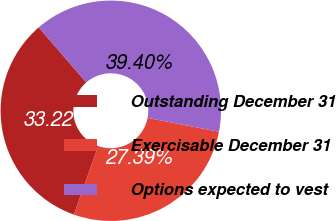Convert chart to OTSL. <chart><loc_0><loc_0><loc_500><loc_500><pie_chart><fcel>Outstanding December 31<fcel>Exercisable December 31<fcel>Options expected to vest<nl><fcel>33.22%<fcel>27.39%<fcel>39.4%<nl></chart> 